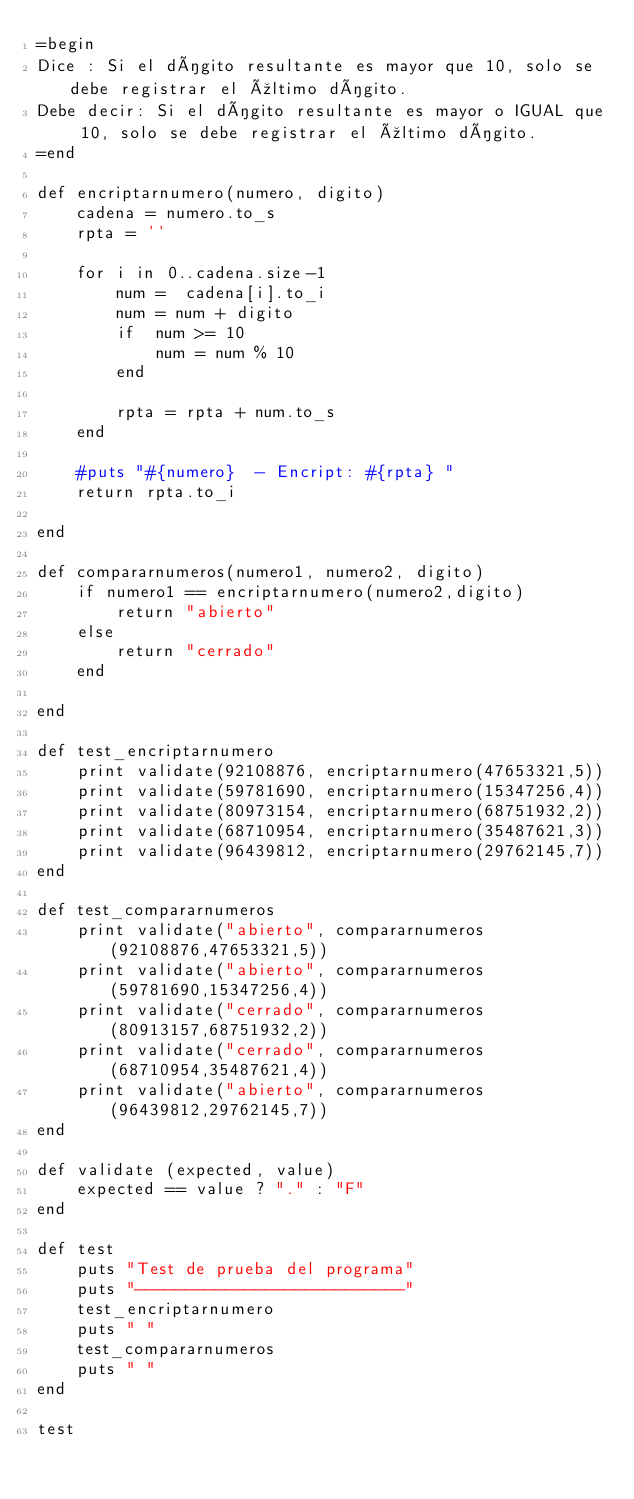<code> <loc_0><loc_0><loc_500><loc_500><_Ruby_>=begin
Dice : Si el dígito resultante es mayor que 10, solo se debe registrar el último dígito.
Debe decir: Si el dígito resultante es mayor o IGUAL que 10, solo se debe registrar el último dígito.
=end

def encriptarnumero(numero, digito)
	cadena = numero.to_s
	rpta = ''

	for i in 0..cadena.size-1
		num =  cadena[i].to_i
		num = num + digito
		if  num >= 10
			num = num % 10
		end

		rpta = rpta + num.to_s
	end

	#puts "#{numero}  - Encript: #{rpta} "
	return rpta.to_i

end

def compararnumeros(numero1, numero2, digito)
	if numero1 == encriptarnumero(numero2,digito)
		return "abierto"
	else
		return "cerrado"
	end

end

def test_encriptarnumero
	print validate(92108876, encriptarnumero(47653321,5))
	print validate(59781690, encriptarnumero(15347256,4))
	print validate(80973154, encriptarnumero(68751932,2))
	print validate(68710954, encriptarnumero(35487621,3))
	print validate(96439812, encriptarnumero(29762145,7))
end

def test_compararnumeros
	print validate("abierto", compararnumeros(92108876,47653321,5))
	print validate("abierto", compararnumeros(59781690,15347256,4))
	print validate("cerrado", compararnumeros(80913157,68751932,2))
	print validate("cerrado", compararnumeros(68710954,35487621,4))
	print validate("abierto", compararnumeros(96439812,29762145,7))
end

def validate (expected, value)
	expected == value ? "." : "F"
end

def test
	puts "Test de prueba del programa"
	puts "---------------------------"
	test_encriptarnumero
	puts " "
	test_compararnumeros
	puts " "
end

test</code> 